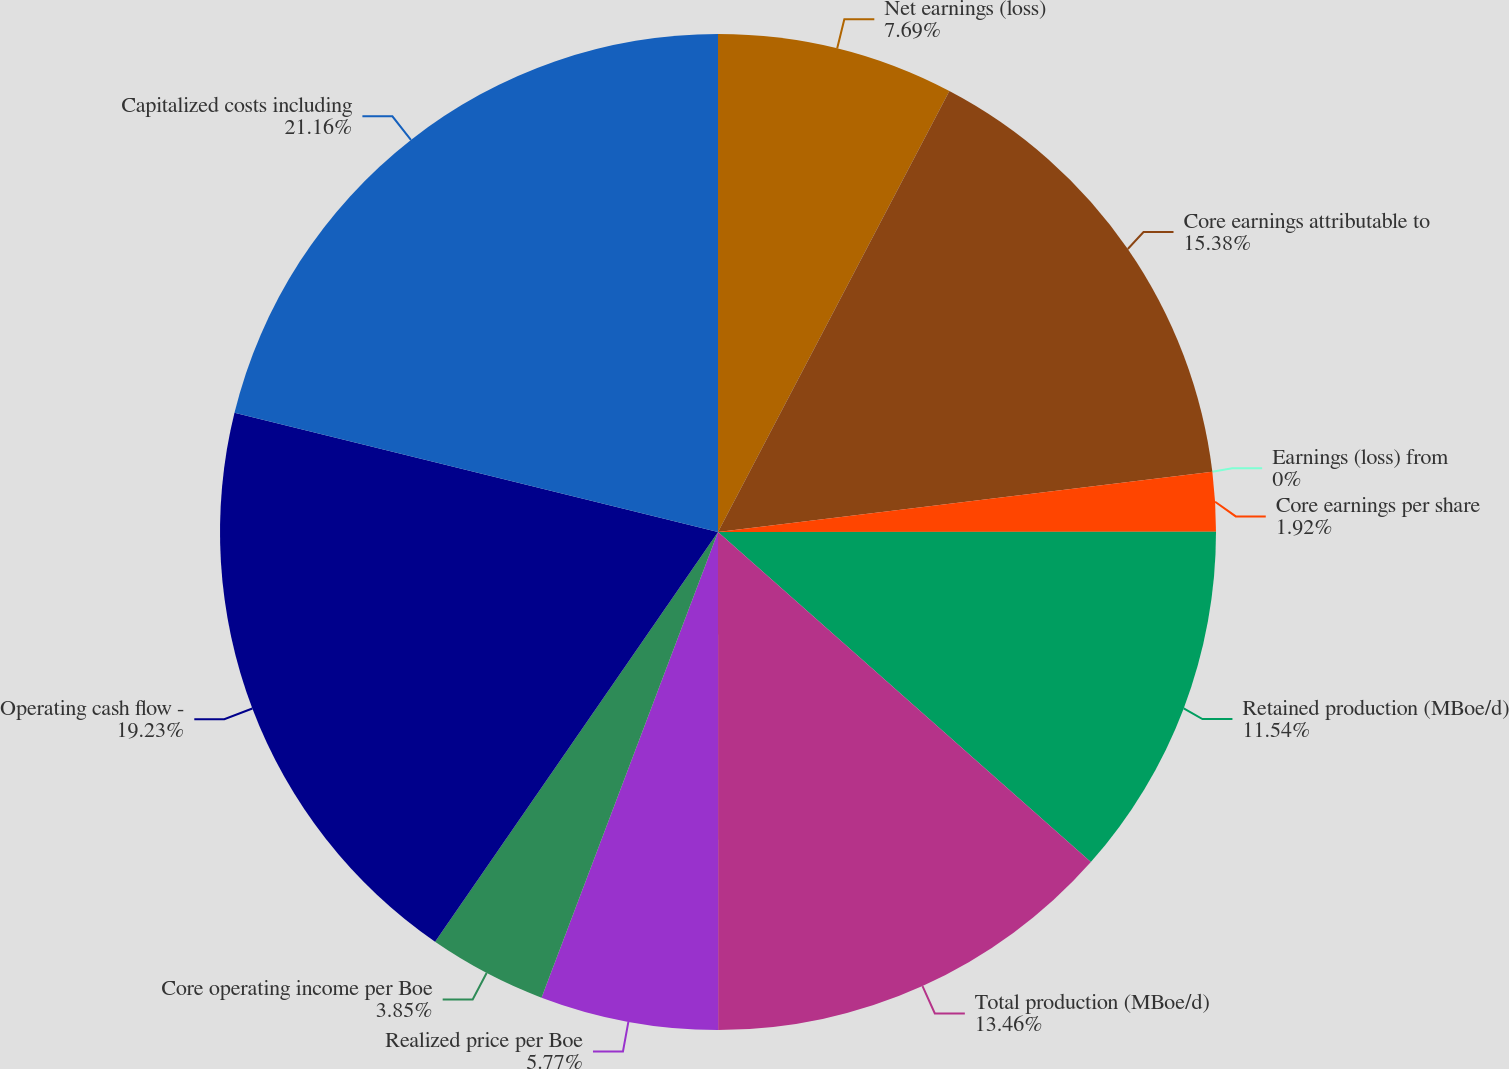Convert chart to OTSL. <chart><loc_0><loc_0><loc_500><loc_500><pie_chart><fcel>Net earnings (loss)<fcel>Core earnings attributable to<fcel>Earnings (loss) from<fcel>Core earnings per share<fcel>Retained production (MBoe/d)<fcel>Total production (MBoe/d)<fcel>Realized price per Boe<fcel>Core operating income per Boe<fcel>Operating cash flow -<fcel>Capitalized costs including<nl><fcel>7.69%<fcel>15.38%<fcel>0.0%<fcel>1.92%<fcel>11.54%<fcel>13.46%<fcel>5.77%<fcel>3.85%<fcel>19.23%<fcel>21.15%<nl></chart> 